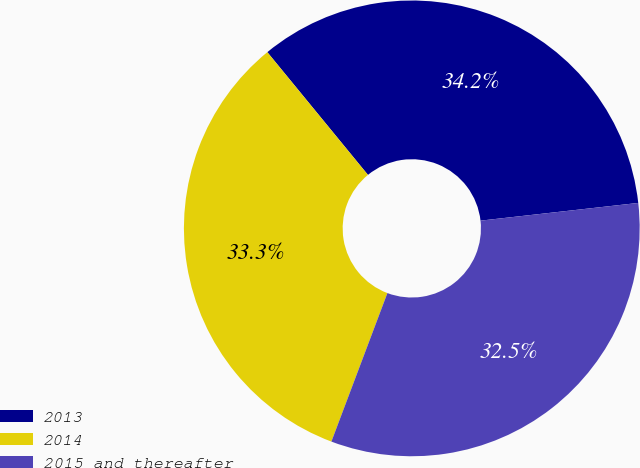Convert chart to OTSL. <chart><loc_0><loc_0><loc_500><loc_500><pie_chart><fcel>2013<fcel>2014<fcel>2015 and thereafter<nl><fcel>34.15%<fcel>33.33%<fcel>32.52%<nl></chart> 